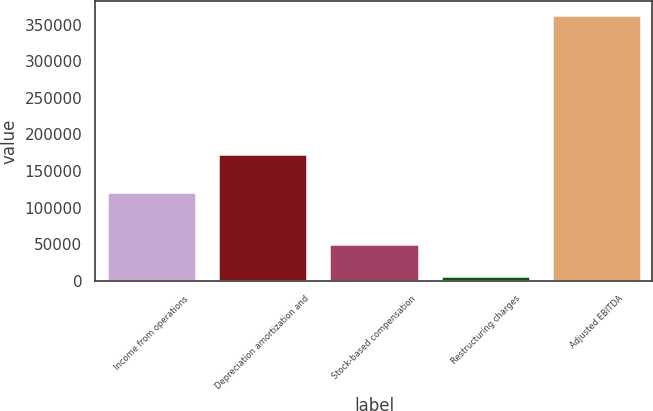<chart> <loc_0><loc_0><loc_500><loc_500><bar_chart><fcel>Income from operations<fcel>Depreciation amortization and<fcel>Stock-based compensation<fcel>Restructuring charges<fcel>Adjusted EBITDA<nl><fcel>121118<fcel>173811<fcel>50966<fcel>6734<fcel>363723<nl></chart> 